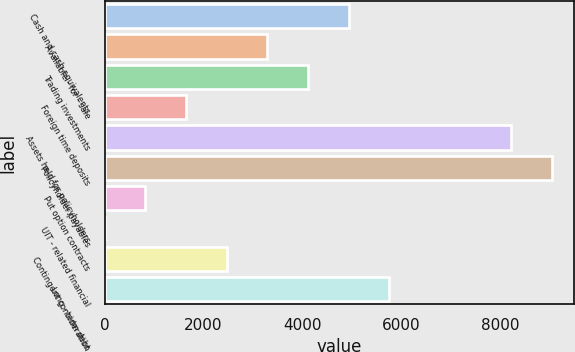Convert chart to OTSL. <chart><loc_0><loc_0><loc_500><loc_500><bar_chart><fcel>Cash and cash equivalents<fcel>Available - for - sale<fcel>Trading investments<fcel>Foreign time deposits<fcel>Assets held for policyholders<fcel>Policyholder payables<fcel>Put option contracts<fcel>UIT - related financial<fcel>Contingent consideration<fcel>Long - term debt<nl><fcel>4936.92<fcel>3293.28<fcel>4115.1<fcel>1649.64<fcel>8224.2<fcel>9046.02<fcel>827.82<fcel>6<fcel>2471.46<fcel>5758.74<nl></chart> 